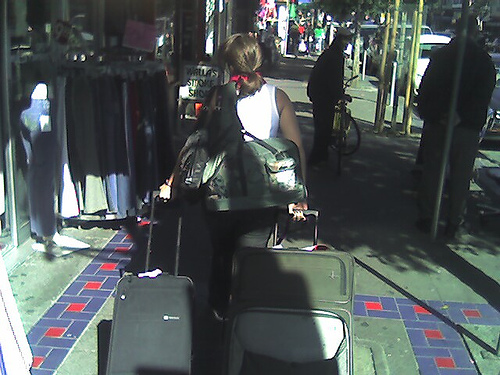Read all the text in this image. WALLAS STONE SHOE 